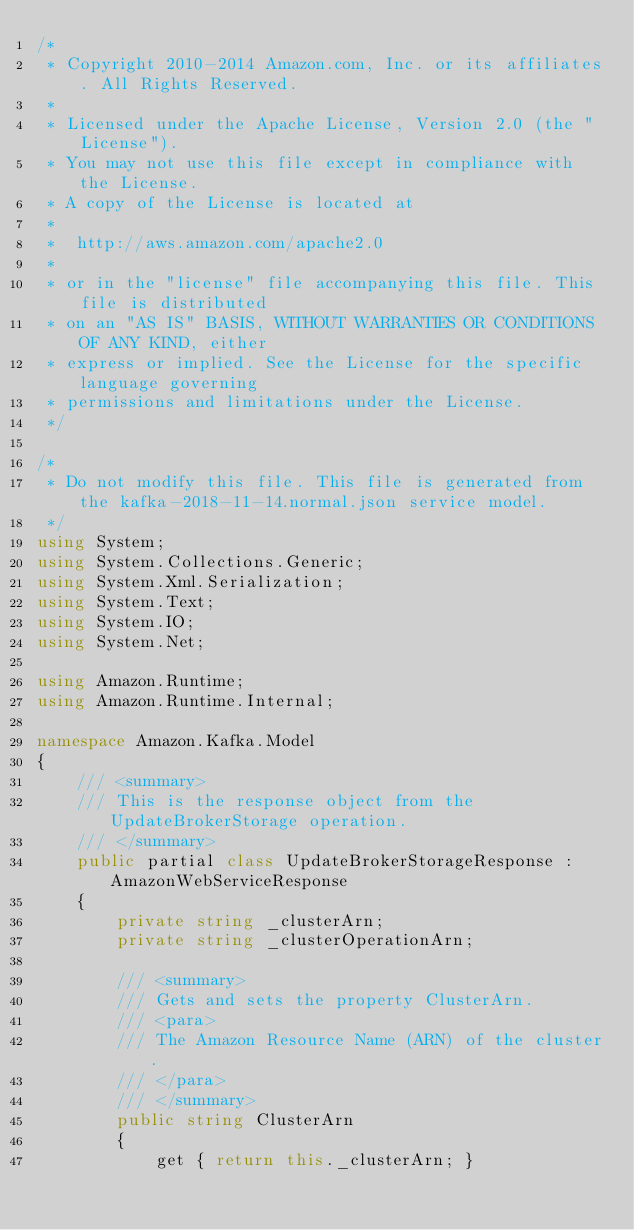<code> <loc_0><loc_0><loc_500><loc_500><_C#_>/*
 * Copyright 2010-2014 Amazon.com, Inc. or its affiliates. All Rights Reserved.
 * 
 * Licensed under the Apache License, Version 2.0 (the "License").
 * You may not use this file except in compliance with the License.
 * A copy of the License is located at
 * 
 *  http://aws.amazon.com/apache2.0
 * 
 * or in the "license" file accompanying this file. This file is distributed
 * on an "AS IS" BASIS, WITHOUT WARRANTIES OR CONDITIONS OF ANY KIND, either
 * express or implied. See the License for the specific language governing
 * permissions and limitations under the License.
 */

/*
 * Do not modify this file. This file is generated from the kafka-2018-11-14.normal.json service model.
 */
using System;
using System.Collections.Generic;
using System.Xml.Serialization;
using System.Text;
using System.IO;
using System.Net;

using Amazon.Runtime;
using Amazon.Runtime.Internal;

namespace Amazon.Kafka.Model
{
    /// <summary>
    /// This is the response object from the UpdateBrokerStorage operation.
    /// </summary>
    public partial class UpdateBrokerStorageResponse : AmazonWebServiceResponse
    {
        private string _clusterArn;
        private string _clusterOperationArn;

        /// <summary>
        /// Gets and sets the property ClusterArn.             
        /// <para>
        /// The Amazon Resource Name (ARN) of the cluster.
        /// </para>
        /// </summary>
        public string ClusterArn
        {
            get { return this._clusterArn; }</code> 